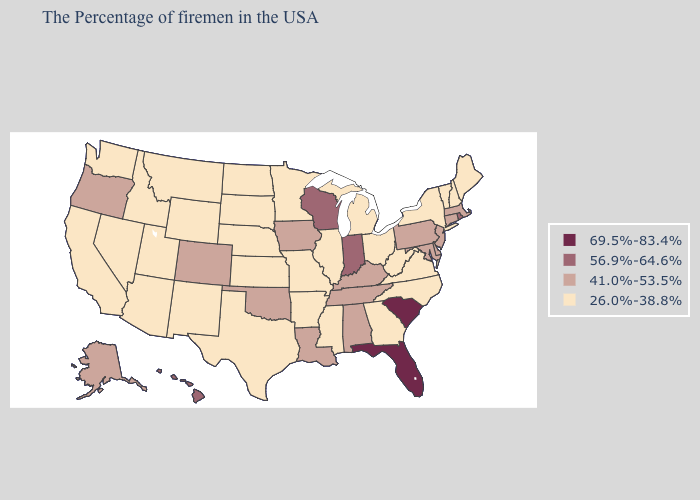Does the first symbol in the legend represent the smallest category?
Give a very brief answer. No. What is the lowest value in states that border New York?
Give a very brief answer. 26.0%-38.8%. Among the states that border Montana , which have the lowest value?
Write a very short answer. South Dakota, North Dakota, Wyoming, Idaho. Does Michigan have the lowest value in the MidWest?
Write a very short answer. Yes. Does Hawaii have the highest value in the West?
Answer briefly. Yes. Among the states that border New Hampshire , which have the highest value?
Keep it brief. Massachusetts. How many symbols are there in the legend?
Write a very short answer. 4. Does the map have missing data?
Keep it brief. No. What is the value of Alabama?
Keep it brief. 41.0%-53.5%. What is the value of Nebraska?
Concise answer only. 26.0%-38.8%. Does Iowa have the highest value in the MidWest?
Keep it brief. No. What is the value of New Jersey?
Give a very brief answer. 41.0%-53.5%. Among the states that border Maine , which have the lowest value?
Short answer required. New Hampshire. 